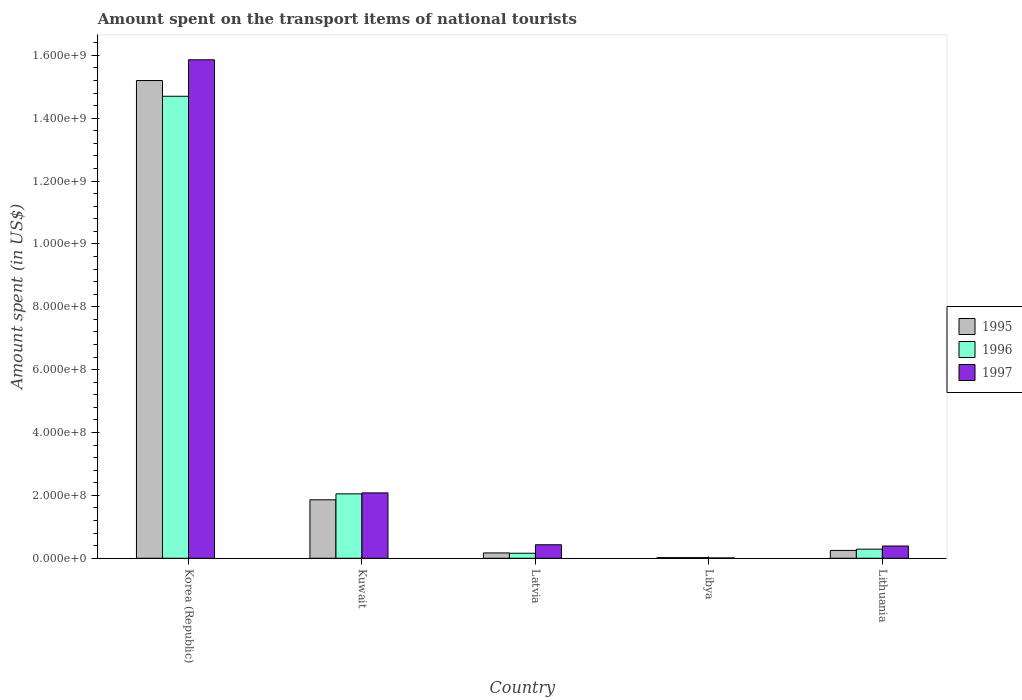How many different coloured bars are there?
Your answer should be very brief. 3. How many groups of bars are there?
Your answer should be compact. 5. How many bars are there on the 2nd tick from the left?
Provide a short and direct response. 3. What is the label of the 3rd group of bars from the left?
Provide a succinct answer. Latvia. What is the amount spent on the transport items of national tourists in 1997 in Lithuania?
Give a very brief answer. 3.90e+07. Across all countries, what is the maximum amount spent on the transport items of national tourists in 1996?
Keep it short and to the point. 1.47e+09. In which country was the amount spent on the transport items of national tourists in 1996 minimum?
Provide a short and direct response. Libya. What is the total amount spent on the transport items of national tourists in 1996 in the graph?
Your response must be concise. 1.72e+09. What is the difference between the amount spent on the transport items of national tourists in 1997 in Libya and that in Lithuania?
Give a very brief answer. -3.80e+07. What is the difference between the amount spent on the transport items of national tourists in 1995 in Latvia and the amount spent on the transport items of national tourists in 1996 in Libya?
Make the answer very short. 1.50e+07. What is the average amount spent on the transport items of national tourists in 1995 per country?
Your response must be concise. 3.50e+08. In how many countries, is the amount spent on the transport items of national tourists in 1996 greater than 160000000 US$?
Give a very brief answer. 2. What is the ratio of the amount spent on the transport items of national tourists in 1997 in Korea (Republic) to that in Latvia?
Keep it short and to the point. 36.88. What is the difference between the highest and the second highest amount spent on the transport items of national tourists in 1997?
Ensure brevity in your answer.  1.38e+09. What is the difference between the highest and the lowest amount spent on the transport items of national tourists in 1996?
Offer a very short reply. 1.47e+09. In how many countries, is the amount spent on the transport items of national tourists in 1996 greater than the average amount spent on the transport items of national tourists in 1996 taken over all countries?
Provide a short and direct response. 1. Is the sum of the amount spent on the transport items of national tourists in 1996 in Libya and Lithuania greater than the maximum amount spent on the transport items of national tourists in 1997 across all countries?
Keep it short and to the point. No. Is it the case that in every country, the sum of the amount spent on the transport items of national tourists in 1995 and amount spent on the transport items of national tourists in 1996 is greater than the amount spent on the transport items of national tourists in 1997?
Make the answer very short. No. How many countries are there in the graph?
Offer a terse response. 5. What is the difference between two consecutive major ticks on the Y-axis?
Offer a very short reply. 2.00e+08. Does the graph contain any zero values?
Offer a terse response. No. Does the graph contain grids?
Keep it short and to the point. No. Where does the legend appear in the graph?
Make the answer very short. Center right. How many legend labels are there?
Offer a very short reply. 3. What is the title of the graph?
Ensure brevity in your answer.  Amount spent on the transport items of national tourists. What is the label or title of the X-axis?
Offer a very short reply. Country. What is the label or title of the Y-axis?
Ensure brevity in your answer.  Amount spent (in US$). What is the Amount spent (in US$) in 1995 in Korea (Republic)?
Give a very brief answer. 1.52e+09. What is the Amount spent (in US$) in 1996 in Korea (Republic)?
Offer a very short reply. 1.47e+09. What is the Amount spent (in US$) in 1997 in Korea (Republic)?
Provide a short and direct response. 1.59e+09. What is the Amount spent (in US$) in 1995 in Kuwait?
Your answer should be very brief. 1.86e+08. What is the Amount spent (in US$) of 1996 in Kuwait?
Your response must be concise. 2.05e+08. What is the Amount spent (in US$) in 1997 in Kuwait?
Keep it short and to the point. 2.08e+08. What is the Amount spent (in US$) of 1995 in Latvia?
Provide a succinct answer. 1.70e+07. What is the Amount spent (in US$) in 1996 in Latvia?
Your answer should be compact. 1.60e+07. What is the Amount spent (in US$) in 1997 in Latvia?
Ensure brevity in your answer.  4.30e+07. What is the Amount spent (in US$) in 1995 in Libya?
Provide a succinct answer. 2.00e+06. What is the Amount spent (in US$) of 1995 in Lithuania?
Offer a very short reply. 2.50e+07. What is the Amount spent (in US$) in 1996 in Lithuania?
Make the answer very short. 2.90e+07. What is the Amount spent (in US$) of 1997 in Lithuania?
Your answer should be compact. 3.90e+07. Across all countries, what is the maximum Amount spent (in US$) in 1995?
Your answer should be compact. 1.52e+09. Across all countries, what is the maximum Amount spent (in US$) in 1996?
Make the answer very short. 1.47e+09. Across all countries, what is the maximum Amount spent (in US$) of 1997?
Your response must be concise. 1.59e+09. Across all countries, what is the minimum Amount spent (in US$) of 1995?
Ensure brevity in your answer.  2.00e+06. What is the total Amount spent (in US$) in 1995 in the graph?
Offer a terse response. 1.75e+09. What is the total Amount spent (in US$) in 1996 in the graph?
Provide a short and direct response. 1.72e+09. What is the total Amount spent (in US$) in 1997 in the graph?
Offer a very short reply. 1.88e+09. What is the difference between the Amount spent (in US$) of 1995 in Korea (Republic) and that in Kuwait?
Your response must be concise. 1.33e+09. What is the difference between the Amount spent (in US$) of 1996 in Korea (Republic) and that in Kuwait?
Give a very brief answer. 1.26e+09. What is the difference between the Amount spent (in US$) of 1997 in Korea (Republic) and that in Kuwait?
Keep it short and to the point. 1.38e+09. What is the difference between the Amount spent (in US$) of 1995 in Korea (Republic) and that in Latvia?
Your response must be concise. 1.50e+09. What is the difference between the Amount spent (in US$) in 1996 in Korea (Republic) and that in Latvia?
Make the answer very short. 1.45e+09. What is the difference between the Amount spent (in US$) of 1997 in Korea (Republic) and that in Latvia?
Provide a short and direct response. 1.54e+09. What is the difference between the Amount spent (in US$) of 1995 in Korea (Republic) and that in Libya?
Offer a very short reply. 1.52e+09. What is the difference between the Amount spent (in US$) in 1996 in Korea (Republic) and that in Libya?
Your answer should be compact. 1.47e+09. What is the difference between the Amount spent (in US$) of 1997 in Korea (Republic) and that in Libya?
Keep it short and to the point. 1.58e+09. What is the difference between the Amount spent (in US$) of 1995 in Korea (Republic) and that in Lithuania?
Your answer should be very brief. 1.50e+09. What is the difference between the Amount spent (in US$) in 1996 in Korea (Republic) and that in Lithuania?
Keep it short and to the point. 1.44e+09. What is the difference between the Amount spent (in US$) in 1997 in Korea (Republic) and that in Lithuania?
Your answer should be very brief. 1.55e+09. What is the difference between the Amount spent (in US$) of 1995 in Kuwait and that in Latvia?
Give a very brief answer. 1.69e+08. What is the difference between the Amount spent (in US$) in 1996 in Kuwait and that in Latvia?
Keep it short and to the point. 1.89e+08. What is the difference between the Amount spent (in US$) of 1997 in Kuwait and that in Latvia?
Your answer should be very brief. 1.65e+08. What is the difference between the Amount spent (in US$) of 1995 in Kuwait and that in Libya?
Offer a terse response. 1.84e+08. What is the difference between the Amount spent (in US$) of 1996 in Kuwait and that in Libya?
Provide a short and direct response. 2.03e+08. What is the difference between the Amount spent (in US$) in 1997 in Kuwait and that in Libya?
Provide a succinct answer. 2.07e+08. What is the difference between the Amount spent (in US$) in 1995 in Kuwait and that in Lithuania?
Offer a very short reply. 1.61e+08. What is the difference between the Amount spent (in US$) of 1996 in Kuwait and that in Lithuania?
Your answer should be compact. 1.76e+08. What is the difference between the Amount spent (in US$) of 1997 in Kuwait and that in Lithuania?
Keep it short and to the point. 1.69e+08. What is the difference between the Amount spent (in US$) in 1995 in Latvia and that in Libya?
Your answer should be very brief. 1.50e+07. What is the difference between the Amount spent (in US$) in 1996 in Latvia and that in Libya?
Keep it short and to the point. 1.40e+07. What is the difference between the Amount spent (in US$) of 1997 in Latvia and that in Libya?
Keep it short and to the point. 4.20e+07. What is the difference between the Amount spent (in US$) in 1995 in Latvia and that in Lithuania?
Make the answer very short. -8.00e+06. What is the difference between the Amount spent (in US$) of 1996 in Latvia and that in Lithuania?
Make the answer very short. -1.30e+07. What is the difference between the Amount spent (in US$) in 1995 in Libya and that in Lithuania?
Offer a terse response. -2.30e+07. What is the difference between the Amount spent (in US$) in 1996 in Libya and that in Lithuania?
Make the answer very short. -2.70e+07. What is the difference between the Amount spent (in US$) in 1997 in Libya and that in Lithuania?
Keep it short and to the point. -3.80e+07. What is the difference between the Amount spent (in US$) of 1995 in Korea (Republic) and the Amount spent (in US$) of 1996 in Kuwait?
Provide a succinct answer. 1.32e+09. What is the difference between the Amount spent (in US$) of 1995 in Korea (Republic) and the Amount spent (in US$) of 1997 in Kuwait?
Your answer should be compact. 1.31e+09. What is the difference between the Amount spent (in US$) in 1996 in Korea (Republic) and the Amount spent (in US$) in 1997 in Kuwait?
Provide a short and direct response. 1.26e+09. What is the difference between the Amount spent (in US$) of 1995 in Korea (Republic) and the Amount spent (in US$) of 1996 in Latvia?
Keep it short and to the point. 1.50e+09. What is the difference between the Amount spent (in US$) of 1995 in Korea (Republic) and the Amount spent (in US$) of 1997 in Latvia?
Offer a terse response. 1.48e+09. What is the difference between the Amount spent (in US$) of 1996 in Korea (Republic) and the Amount spent (in US$) of 1997 in Latvia?
Give a very brief answer. 1.43e+09. What is the difference between the Amount spent (in US$) of 1995 in Korea (Republic) and the Amount spent (in US$) of 1996 in Libya?
Your response must be concise. 1.52e+09. What is the difference between the Amount spent (in US$) of 1995 in Korea (Republic) and the Amount spent (in US$) of 1997 in Libya?
Your answer should be very brief. 1.52e+09. What is the difference between the Amount spent (in US$) in 1996 in Korea (Republic) and the Amount spent (in US$) in 1997 in Libya?
Your response must be concise. 1.47e+09. What is the difference between the Amount spent (in US$) in 1995 in Korea (Republic) and the Amount spent (in US$) in 1996 in Lithuania?
Offer a very short reply. 1.49e+09. What is the difference between the Amount spent (in US$) in 1995 in Korea (Republic) and the Amount spent (in US$) in 1997 in Lithuania?
Offer a very short reply. 1.48e+09. What is the difference between the Amount spent (in US$) in 1996 in Korea (Republic) and the Amount spent (in US$) in 1997 in Lithuania?
Offer a terse response. 1.43e+09. What is the difference between the Amount spent (in US$) in 1995 in Kuwait and the Amount spent (in US$) in 1996 in Latvia?
Provide a short and direct response. 1.70e+08. What is the difference between the Amount spent (in US$) of 1995 in Kuwait and the Amount spent (in US$) of 1997 in Latvia?
Your answer should be very brief. 1.43e+08. What is the difference between the Amount spent (in US$) in 1996 in Kuwait and the Amount spent (in US$) in 1997 in Latvia?
Ensure brevity in your answer.  1.62e+08. What is the difference between the Amount spent (in US$) of 1995 in Kuwait and the Amount spent (in US$) of 1996 in Libya?
Your answer should be compact. 1.84e+08. What is the difference between the Amount spent (in US$) in 1995 in Kuwait and the Amount spent (in US$) in 1997 in Libya?
Offer a terse response. 1.85e+08. What is the difference between the Amount spent (in US$) in 1996 in Kuwait and the Amount spent (in US$) in 1997 in Libya?
Keep it short and to the point. 2.04e+08. What is the difference between the Amount spent (in US$) of 1995 in Kuwait and the Amount spent (in US$) of 1996 in Lithuania?
Offer a very short reply. 1.57e+08. What is the difference between the Amount spent (in US$) in 1995 in Kuwait and the Amount spent (in US$) in 1997 in Lithuania?
Make the answer very short. 1.47e+08. What is the difference between the Amount spent (in US$) of 1996 in Kuwait and the Amount spent (in US$) of 1997 in Lithuania?
Ensure brevity in your answer.  1.66e+08. What is the difference between the Amount spent (in US$) of 1995 in Latvia and the Amount spent (in US$) of 1996 in Libya?
Keep it short and to the point. 1.50e+07. What is the difference between the Amount spent (in US$) in 1995 in Latvia and the Amount spent (in US$) in 1997 in Libya?
Your response must be concise. 1.60e+07. What is the difference between the Amount spent (in US$) in 1996 in Latvia and the Amount spent (in US$) in 1997 in Libya?
Your response must be concise. 1.50e+07. What is the difference between the Amount spent (in US$) of 1995 in Latvia and the Amount spent (in US$) of 1996 in Lithuania?
Keep it short and to the point. -1.20e+07. What is the difference between the Amount spent (in US$) of 1995 in Latvia and the Amount spent (in US$) of 1997 in Lithuania?
Your response must be concise. -2.20e+07. What is the difference between the Amount spent (in US$) of 1996 in Latvia and the Amount spent (in US$) of 1997 in Lithuania?
Your answer should be very brief. -2.30e+07. What is the difference between the Amount spent (in US$) of 1995 in Libya and the Amount spent (in US$) of 1996 in Lithuania?
Make the answer very short. -2.70e+07. What is the difference between the Amount spent (in US$) of 1995 in Libya and the Amount spent (in US$) of 1997 in Lithuania?
Give a very brief answer. -3.70e+07. What is the difference between the Amount spent (in US$) in 1996 in Libya and the Amount spent (in US$) in 1997 in Lithuania?
Your answer should be compact. -3.70e+07. What is the average Amount spent (in US$) of 1995 per country?
Provide a short and direct response. 3.50e+08. What is the average Amount spent (in US$) in 1996 per country?
Offer a terse response. 3.44e+08. What is the average Amount spent (in US$) of 1997 per country?
Offer a terse response. 3.75e+08. What is the difference between the Amount spent (in US$) in 1995 and Amount spent (in US$) in 1996 in Korea (Republic)?
Your response must be concise. 5.00e+07. What is the difference between the Amount spent (in US$) of 1995 and Amount spent (in US$) of 1997 in Korea (Republic)?
Ensure brevity in your answer.  -6.60e+07. What is the difference between the Amount spent (in US$) in 1996 and Amount spent (in US$) in 1997 in Korea (Republic)?
Your response must be concise. -1.16e+08. What is the difference between the Amount spent (in US$) in 1995 and Amount spent (in US$) in 1996 in Kuwait?
Offer a terse response. -1.90e+07. What is the difference between the Amount spent (in US$) in 1995 and Amount spent (in US$) in 1997 in Kuwait?
Ensure brevity in your answer.  -2.20e+07. What is the difference between the Amount spent (in US$) of 1996 and Amount spent (in US$) of 1997 in Kuwait?
Your answer should be compact. -3.00e+06. What is the difference between the Amount spent (in US$) in 1995 and Amount spent (in US$) in 1996 in Latvia?
Offer a very short reply. 1.00e+06. What is the difference between the Amount spent (in US$) of 1995 and Amount spent (in US$) of 1997 in Latvia?
Provide a succinct answer. -2.60e+07. What is the difference between the Amount spent (in US$) of 1996 and Amount spent (in US$) of 1997 in Latvia?
Provide a succinct answer. -2.70e+07. What is the difference between the Amount spent (in US$) in 1995 and Amount spent (in US$) in 1996 in Libya?
Keep it short and to the point. 0. What is the difference between the Amount spent (in US$) of 1995 and Amount spent (in US$) of 1997 in Libya?
Ensure brevity in your answer.  1.00e+06. What is the difference between the Amount spent (in US$) of 1995 and Amount spent (in US$) of 1997 in Lithuania?
Your answer should be very brief. -1.40e+07. What is the difference between the Amount spent (in US$) in 1996 and Amount spent (in US$) in 1997 in Lithuania?
Ensure brevity in your answer.  -1.00e+07. What is the ratio of the Amount spent (in US$) of 1995 in Korea (Republic) to that in Kuwait?
Your answer should be very brief. 8.17. What is the ratio of the Amount spent (in US$) of 1996 in Korea (Republic) to that in Kuwait?
Give a very brief answer. 7.17. What is the ratio of the Amount spent (in US$) in 1997 in Korea (Republic) to that in Kuwait?
Ensure brevity in your answer.  7.62. What is the ratio of the Amount spent (in US$) in 1995 in Korea (Republic) to that in Latvia?
Offer a terse response. 89.41. What is the ratio of the Amount spent (in US$) of 1996 in Korea (Republic) to that in Latvia?
Give a very brief answer. 91.88. What is the ratio of the Amount spent (in US$) in 1997 in Korea (Republic) to that in Latvia?
Make the answer very short. 36.88. What is the ratio of the Amount spent (in US$) in 1995 in Korea (Republic) to that in Libya?
Ensure brevity in your answer.  760. What is the ratio of the Amount spent (in US$) in 1996 in Korea (Republic) to that in Libya?
Your answer should be very brief. 735. What is the ratio of the Amount spent (in US$) in 1997 in Korea (Republic) to that in Libya?
Provide a short and direct response. 1586. What is the ratio of the Amount spent (in US$) of 1995 in Korea (Republic) to that in Lithuania?
Your response must be concise. 60.8. What is the ratio of the Amount spent (in US$) of 1996 in Korea (Republic) to that in Lithuania?
Your answer should be compact. 50.69. What is the ratio of the Amount spent (in US$) of 1997 in Korea (Republic) to that in Lithuania?
Provide a short and direct response. 40.67. What is the ratio of the Amount spent (in US$) in 1995 in Kuwait to that in Latvia?
Make the answer very short. 10.94. What is the ratio of the Amount spent (in US$) in 1996 in Kuwait to that in Latvia?
Offer a terse response. 12.81. What is the ratio of the Amount spent (in US$) of 1997 in Kuwait to that in Latvia?
Your answer should be compact. 4.84. What is the ratio of the Amount spent (in US$) in 1995 in Kuwait to that in Libya?
Offer a terse response. 93. What is the ratio of the Amount spent (in US$) in 1996 in Kuwait to that in Libya?
Your response must be concise. 102.5. What is the ratio of the Amount spent (in US$) of 1997 in Kuwait to that in Libya?
Keep it short and to the point. 208. What is the ratio of the Amount spent (in US$) in 1995 in Kuwait to that in Lithuania?
Offer a very short reply. 7.44. What is the ratio of the Amount spent (in US$) of 1996 in Kuwait to that in Lithuania?
Your response must be concise. 7.07. What is the ratio of the Amount spent (in US$) in 1997 in Kuwait to that in Lithuania?
Provide a succinct answer. 5.33. What is the ratio of the Amount spent (in US$) in 1995 in Latvia to that in Libya?
Provide a short and direct response. 8.5. What is the ratio of the Amount spent (in US$) in 1996 in Latvia to that in Libya?
Offer a very short reply. 8. What is the ratio of the Amount spent (in US$) in 1997 in Latvia to that in Libya?
Your answer should be very brief. 43. What is the ratio of the Amount spent (in US$) of 1995 in Latvia to that in Lithuania?
Provide a succinct answer. 0.68. What is the ratio of the Amount spent (in US$) of 1996 in Latvia to that in Lithuania?
Offer a terse response. 0.55. What is the ratio of the Amount spent (in US$) of 1997 in Latvia to that in Lithuania?
Offer a terse response. 1.1. What is the ratio of the Amount spent (in US$) in 1995 in Libya to that in Lithuania?
Make the answer very short. 0.08. What is the ratio of the Amount spent (in US$) in 1996 in Libya to that in Lithuania?
Keep it short and to the point. 0.07. What is the ratio of the Amount spent (in US$) in 1997 in Libya to that in Lithuania?
Offer a terse response. 0.03. What is the difference between the highest and the second highest Amount spent (in US$) in 1995?
Provide a short and direct response. 1.33e+09. What is the difference between the highest and the second highest Amount spent (in US$) of 1996?
Provide a short and direct response. 1.26e+09. What is the difference between the highest and the second highest Amount spent (in US$) of 1997?
Your answer should be very brief. 1.38e+09. What is the difference between the highest and the lowest Amount spent (in US$) of 1995?
Make the answer very short. 1.52e+09. What is the difference between the highest and the lowest Amount spent (in US$) in 1996?
Offer a terse response. 1.47e+09. What is the difference between the highest and the lowest Amount spent (in US$) in 1997?
Your answer should be compact. 1.58e+09. 